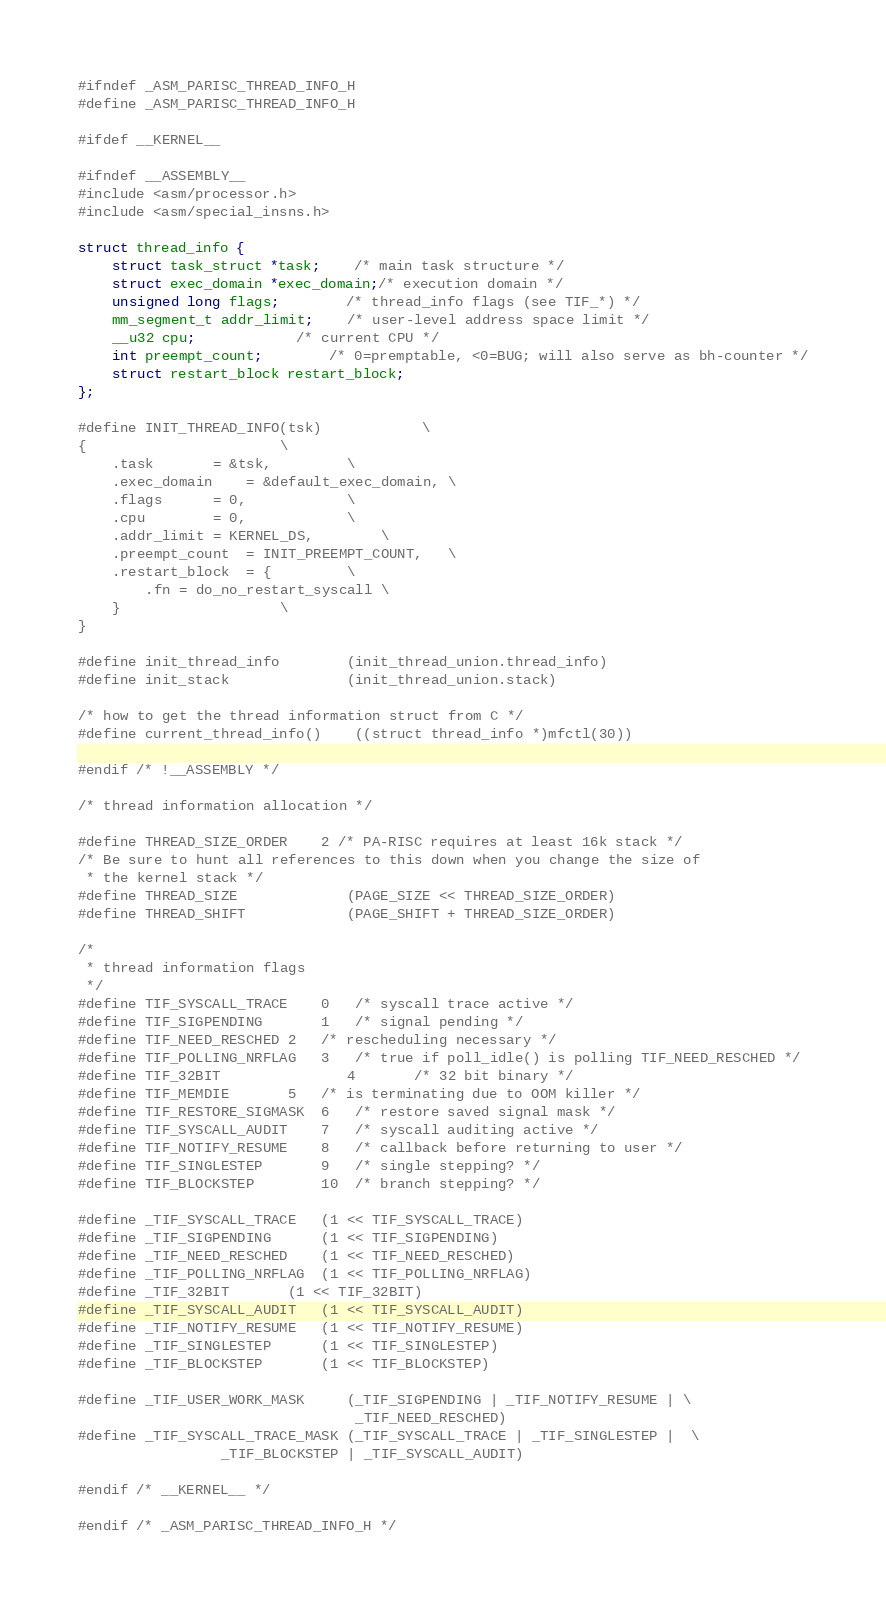Convert code to text. <code><loc_0><loc_0><loc_500><loc_500><_C_>#ifndef _ASM_PARISC_THREAD_INFO_H
#define _ASM_PARISC_THREAD_INFO_H

#ifdef __KERNEL__

#ifndef __ASSEMBLY__
#include <asm/processor.h>
#include <asm/special_insns.h>

struct thread_info {
	struct task_struct *task;	/* main task structure */
	struct exec_domain *exec_domain;/* execution domain */
	unsigned long flags;		/* thread_info flags (see TIF_*) */
	mm_segment_t addr_limit;	/* user-level address space limit */
	__u32 cpu;			/* current CPU */
	int preempt_count;		/* 0=premptable, <0=BUG; will also serve as bh-counter */
	struct restart_block restart_block;
};

#define INIT_THREAD_INFO(tsk)			\
{						\
	.task		= &tsk,			\
	.exec_domain	= &default_exec_domain,	\
	.flags		= 0,			\
	.cpu		= 0,			\
	.addr_limit	= KERNEL_DS,		\
	.preempt_count	= INIT_PREEMPT_COUNT,	\
  	.restart_block	= {			\
		.fn = do_no_restart_syscall	\
	}					\
}

#define init_thread_info        (init_thread_union.thread_info)
#define init_stack              (init_thread_union.stack)

/* how to get the thread information struct from C */
#define current_thread_info()	((struct thread_info *)mfctl(30))

#endif /* !__ASSEMBLY */

/* thread information allocation */

#define THREAD_SIZE_ORDER	2 /* PA-RISC requires at least 16k stack */
/* Be sure to hunt all references to this down when you change the size of
 * the kernel stack */
#define THREAD_SIZE             (PAGE_SIZE << THREAD_SIZE_ORDER)
#define THREAD_SHIFT            (PAGE_SHIFT + THREAD_SIZE_ORDER)

/*
 * thread information flags
 */
#define TIF_SYSCALL_TRACE	0	/* syscall trace active */
#define TIF_SIGPENDING		1	/* signal pending */
#define TIF_NEED_RESCHED	2	/* rescheduling necessary */
#define TIF_POLLING_NRFLAG	3	/* true if poll_idle() is polling TIF_NEED_RESCHED */
#define TIF_32BIT               4       /* 32 bit binary */
#define TIF_MEMDIE		5	/* is terminating due to OOM killer */
#define TIF_RESTORE_SIGMASK	6	/* restore saved signal mask */
#define TIF_SYSCALL_AUDIT	7	/* syscall auditing active */
#define TIF_NOTIFY_RESUME	8	/* callback before returning to user */
#define TIF_SINGLESTEP		9	/* single stepping? */
#define TIF_BLOCKSTEP		10	/* branch stepping? */

#define _TIF_SYSCALL_TRACE	(1 << TIF_SYSCALL_TRACE)
#define _TIF_SIGPENDING		(1 << TIF_SIGPENDING)
#define _TIF_NEED_RESCHED	(1 << TIF_NEED_RESCHED)
#define _TIF_POLLING_NRFLAG	(1 << TIF_POLLING_NRFLAG)
#define _TIF_32BIT		(1 << TIF_32BIT)
#define _TIF_SYSCALL_AUDIT	(1 << TIF_SYSCALL_AUDIT)
#define _TIF_NOTIFY_RESUME	(1 << TIF_NOTIFY_RESUME)
#define _TIF_SINGLESTEP		(1 << TIF_SINGLESTEP)
#define _TIF_BLOCKSTEP		(1 << TIF_BLOCKSTEP)

#define _TIF_USER_WORK_MASK     (_TIF_SIGPENDING | _TIF_NOTIFY_RESUME | \
                                 _TIF_NEED_RESCHED)
#define _TIF_SYSCALL_TRACE_MASK (_TIF_SYSCALL_TRACE | _TIF_SINGLESTEP |	\
				 _TIF_BLOCKSTEP | _TIF_SYSCALL_AUDIT)

#endif /* __KERNEL__ */

#endif /* _ASM_PARISC_THREAD_INFO_H */
</code> 